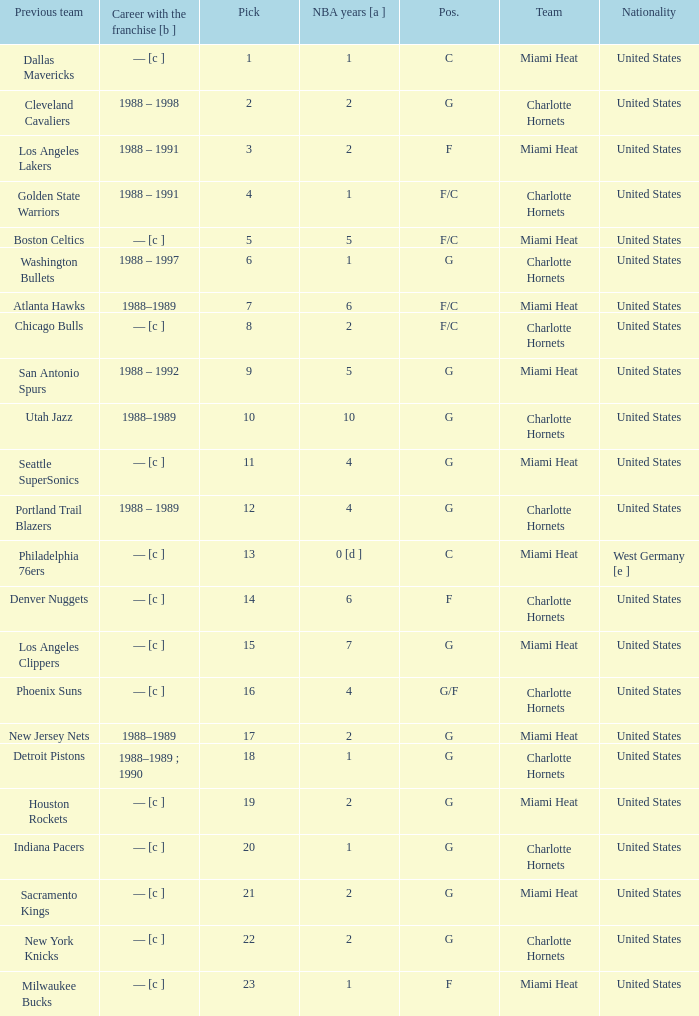What is the previous team of the player with 4 NBA years and a pick less than 16? Seattle SuperSonics, Portland Trail Blazers. 